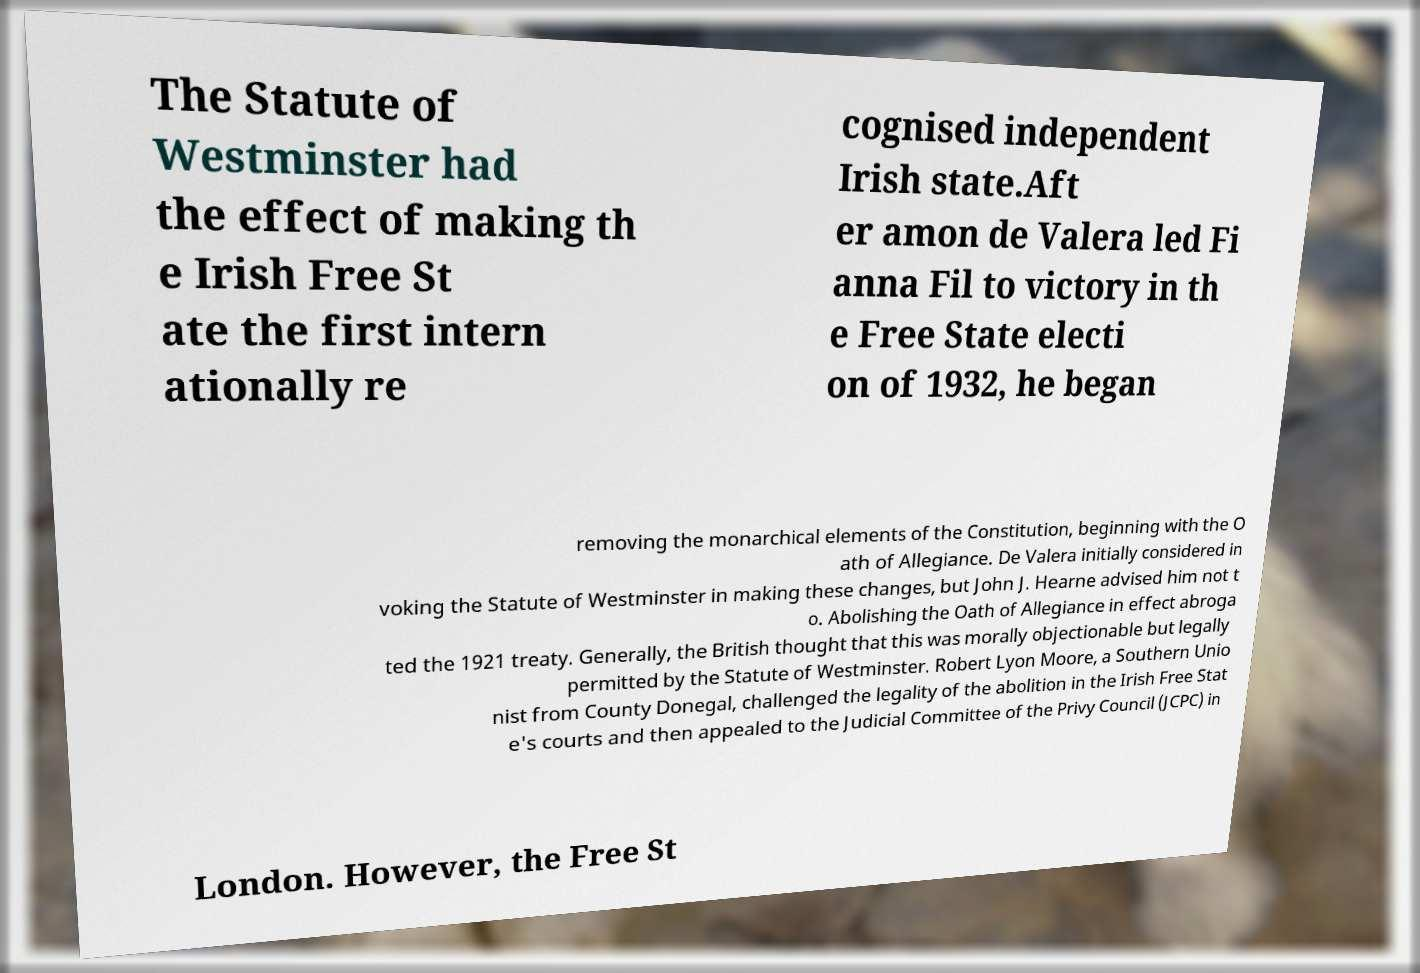I need the written content from this picture converted into text. Can you do that? The Statute of Westminster had the effect of making th e Irish Free St ate the first intern ationally re cognised independent Irish state.Aft er amon de Valera led Fi anna Fil to victory in th e Free State electi on of 1932, he began removing the monarchical elements of the Constitution, beginning with the O ath of Allegiance. De Valera initially considered in voking the Statute of Westminster in making these changes, but John J. Hearne advised him not t o. Abolishing the Oath of Allegiance in effect abroga ted the 1921 treaty. Generally, the British thought that this was morally objectionable but legally permitted by the Statute of Westminster. Robert Lyon Moore, a Southern Unio nist from County Donegal, challenged the legality of the abolition in the Irish Free Stat e's courts and then appealed to the Judicial Committee of the Privy Council (JCPC) in London. However, the Free St 